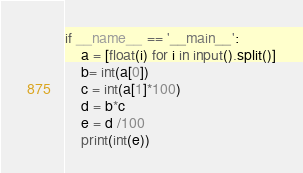Convert code to text. <code><loc_0><loc_0><loc_500><loc_500><_Python_>if __name__ == '__main__':
    a = [float(i) for i in input().split()]
    b= int(a[0])
    c = int(a[1]*100)
    d = b*c
    e = d /100
    print(int(e))
</code> 